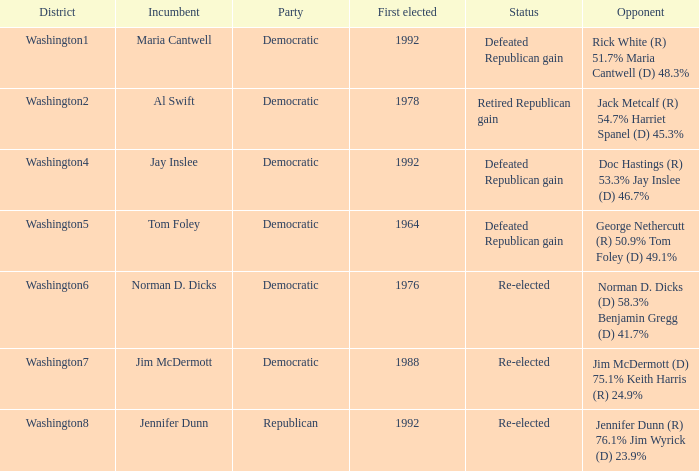7%? Defeated Republican gain. 